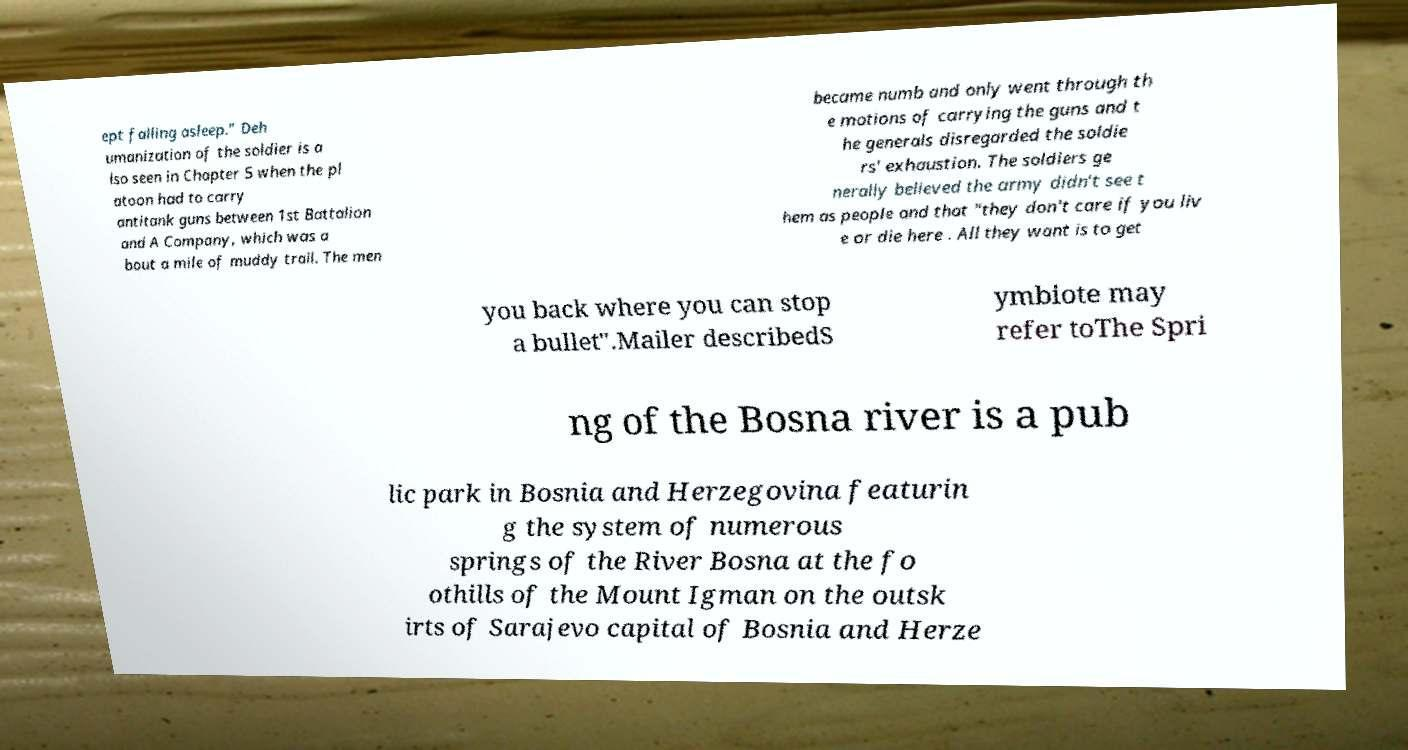Could you extract and type out the text from this image? ept falling asleep.” Deh umanization of the soldier is a lso seen in Chapter 5 when the pl atoon had to carry antitank guns between 1st Battalion and A Company, which was a bout a mile of muddy trail. The men became numb and only went through th e motions of carrying the guns and t he generals disregarded the soldie rs' exhaustion. The soldiers ge nerally believed the army didn't see t hem as people and that "they don't care if you liv e or die here . All they want is to get you back where you can stop a bullet".Mailer describedS ymbiote may refer toThe Spri ng of the Bosna river is a pub lic park in Bosnia and Herzegovina featurin g the system of numerous springs of the River Bosna at the fo othills of the Mount Igman on the outsk irts of Sarajevo capital of Bosnia and Herze 